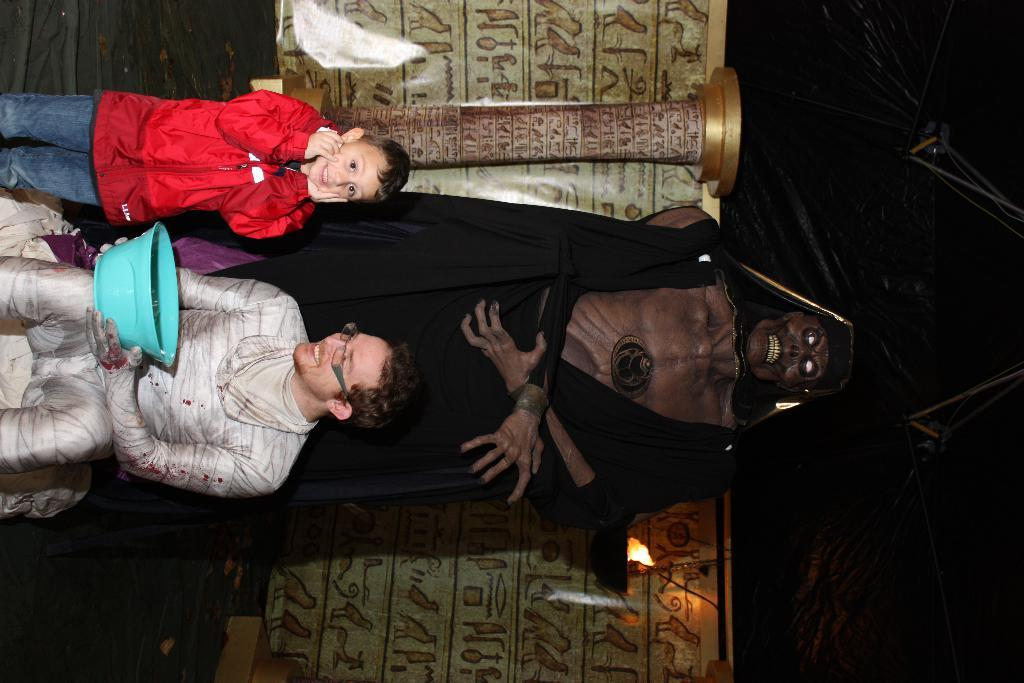What is the person in the image doing? The person is sitting on a bench on the left side of the image. What is the kid doing in the image? The kid is standing on the ground in the image. What can be seen in the background of the image? There is a statue, a pillar, a light, and a wall in the background of the image. What type of vessel is being used to order the smell in the image? There is no vessel or smell present in the image. What type of order is being followed by the statue in the image? There is no order being followed by the statue in the image; it is a stationary object. 